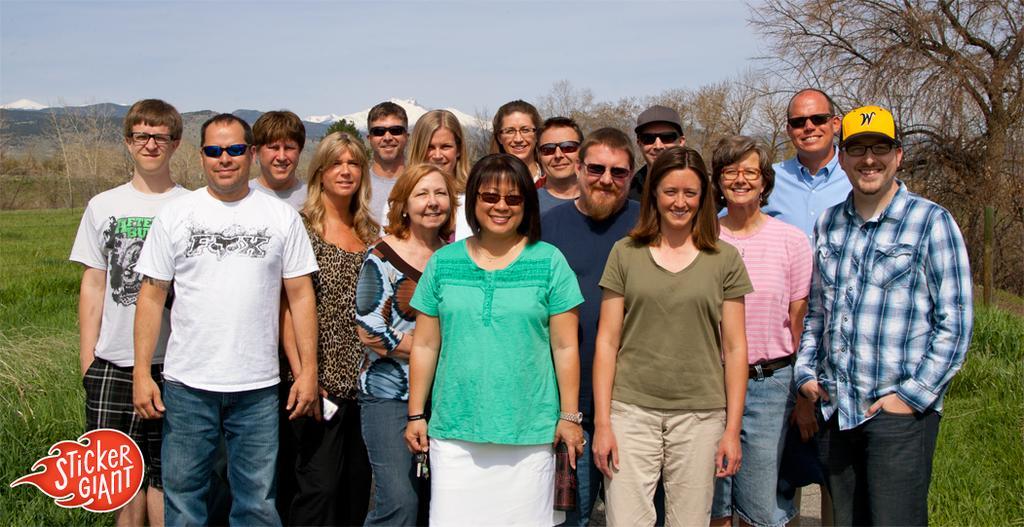How would you summarize this image in a sentence or two? There are many people standing. Some are wearing goggles and caps. In the back there is grasses, trees and sky. There is a watermark on the left corner. 